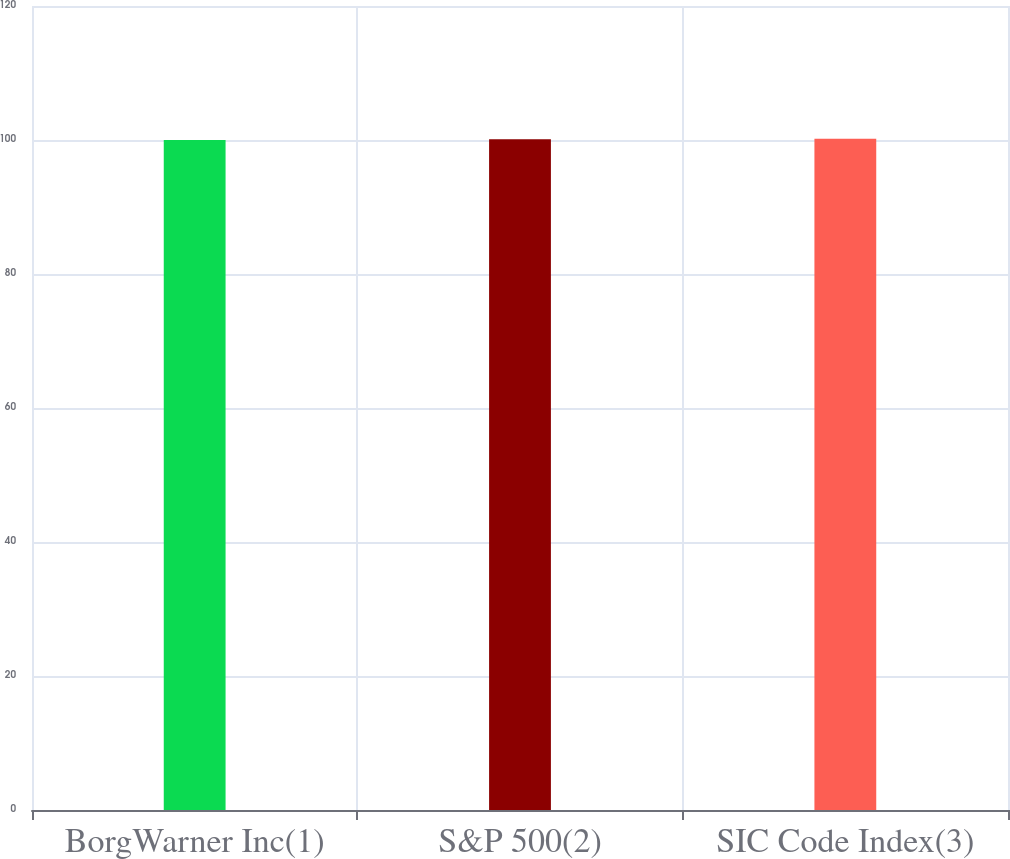Convert chart. <chart><loc_0><loc_0><loc_500><loc_500><bar_chart><fcel>BorgWarner Inc(1)<fcel>S&P 500(2)<fcel>SIC Code Index(3)<nl><fcel>100<fcel>100.1<fcel>100.2<nl></chart> 